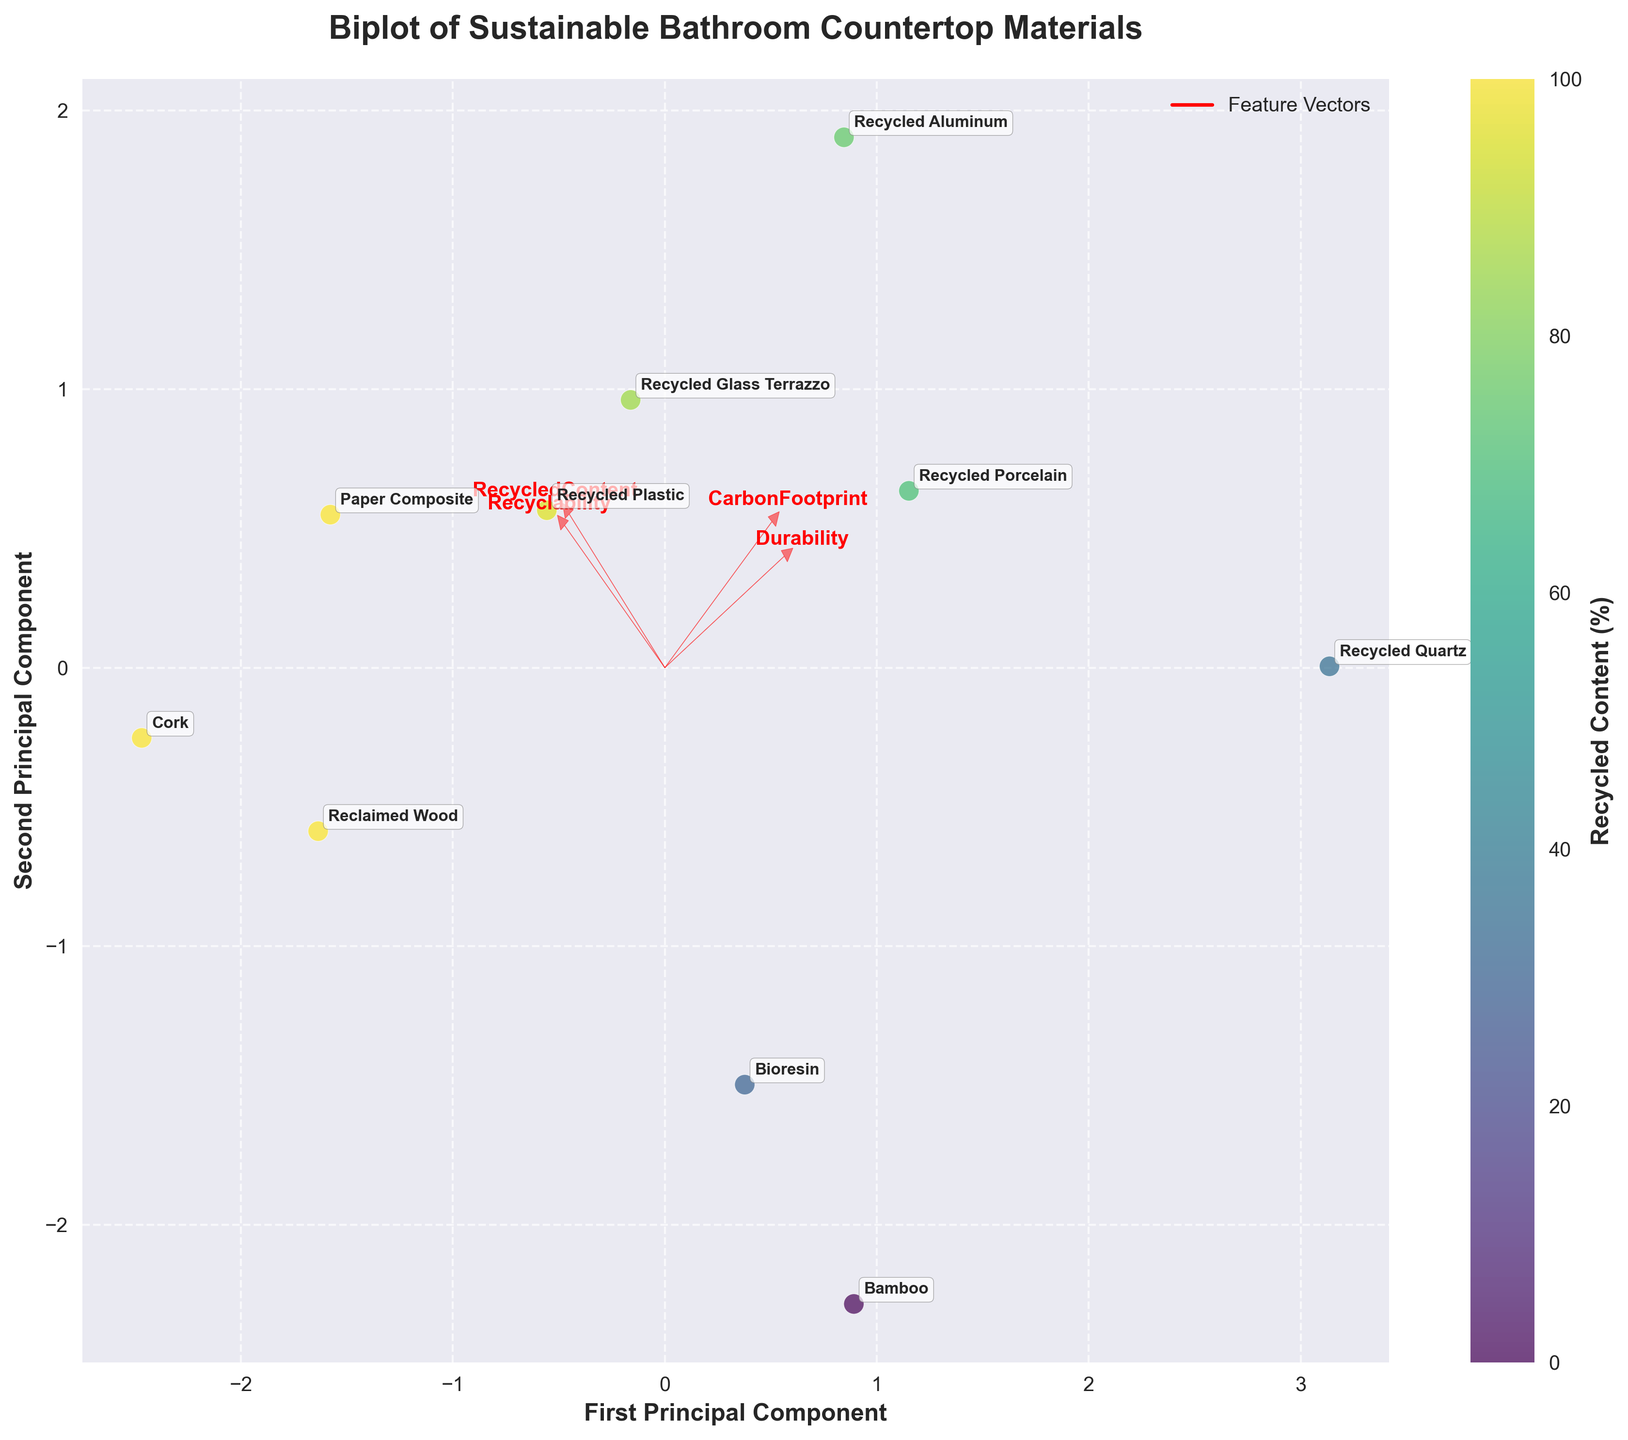What is the title of the plot? The title of the plot is located at the top and is the largest text on the figure. It provides a clear description of the plotted data, which is "Biplot of Sustainable Bathroom Countertop Materials."
Answer: Biplot of Sustainable Bathroom Countertop Materials Which material has the highest recycled content percentage? Recycled content percentages are represented by the color gradient in the plot. The material with the highest recycled content will have the darkest color in the colormap. From the figure, "Paper Composite," "Reclaimed Wood," and "Cork" all have a recycled content percentage of 100%.
Answer: Paper Composite, Reclaimed Wood, or Cork Which material has the lowest carbon footprint? The carbon footprint of each material can be inferred from the positions of the points and the directions of the feature vectors. "Cork" is closest to the negative direction of the "CarbonFootprint" arrow, indicating it has the lowest carbon footprint.
Answer: Cork Which materials are closest to the origin in the biplot? Materials closest to the origin have the most balanced scores across the measured features. These are "Recycled Plastic" and "Bioresin," as they are plotted near the center of the graph.
Answer: Recycled Plastic and Bioresin Among recycled glass terrazzo and recycled aluminum, which has a higher recyclability? Recyclability is indicated by the projection on the "Recyclability" arrow. "Recycled Aluminum" is further in the positive direction of the "Recyclability" arrow compared to "Recycled Glass Terrazzo."
Answer: Recycled Aluminum What can you infer about the relationship between recycled content and carbon footprint? The directions of the "RecycledContent" and "CarbonFootprint" feature vectors provide insight. They point roughly in opposite directions, suggesting a negative correlation: materials with higher recycled content tend to have a lower carbon footprint.
Answer: Negative correlation Which material scores highest on durability? The arrow labeled "Durability" indicates the direction of increasing durability. "Recycled Quartz" is the furthest along this arrow from the origin.
Answer: Recycled Quartz What does the spread of the points suggest about the diversity of materials? The spread of points in the biplot suggests there is a wide range of properties among the materials, meaning variation in recycled content, carbon footprint, recyclability, and durability is significant.
Answer: Wide range of properties Rank the materials by their recyclability from highest to lowest. By referring to the projections on the "Recyclability" arrow, the ranking from highest to lowest recyclability is "Paper Composite," "Cork," "Recycled Aluminum," "Recycled Plastic," "Reclaimed Wood," "Recycled Glass Terrazzo," "Bioresin," "Bamboo," and "Recycled Quartz."
Answer: Paper Composite, Cork, Recycled Aluminum, Recycled Plastic, Reclaimed Wood, Recycled Glass Terrazzo, Bioresin, Bamboo, Recycled Quartz Explain the meaning of the feature vectors (arrows) in the biplot. Feature vectors indicate the direction and relative magnitude of each feature (Recycled Content, Carbon Footprint, Recyclability, Durability). The arrows show which direction the feature increases and how much each feature contributes to the variance explained by the principal components. Longer vectors indicate higher significance.
Answer: Direction and significance of features 